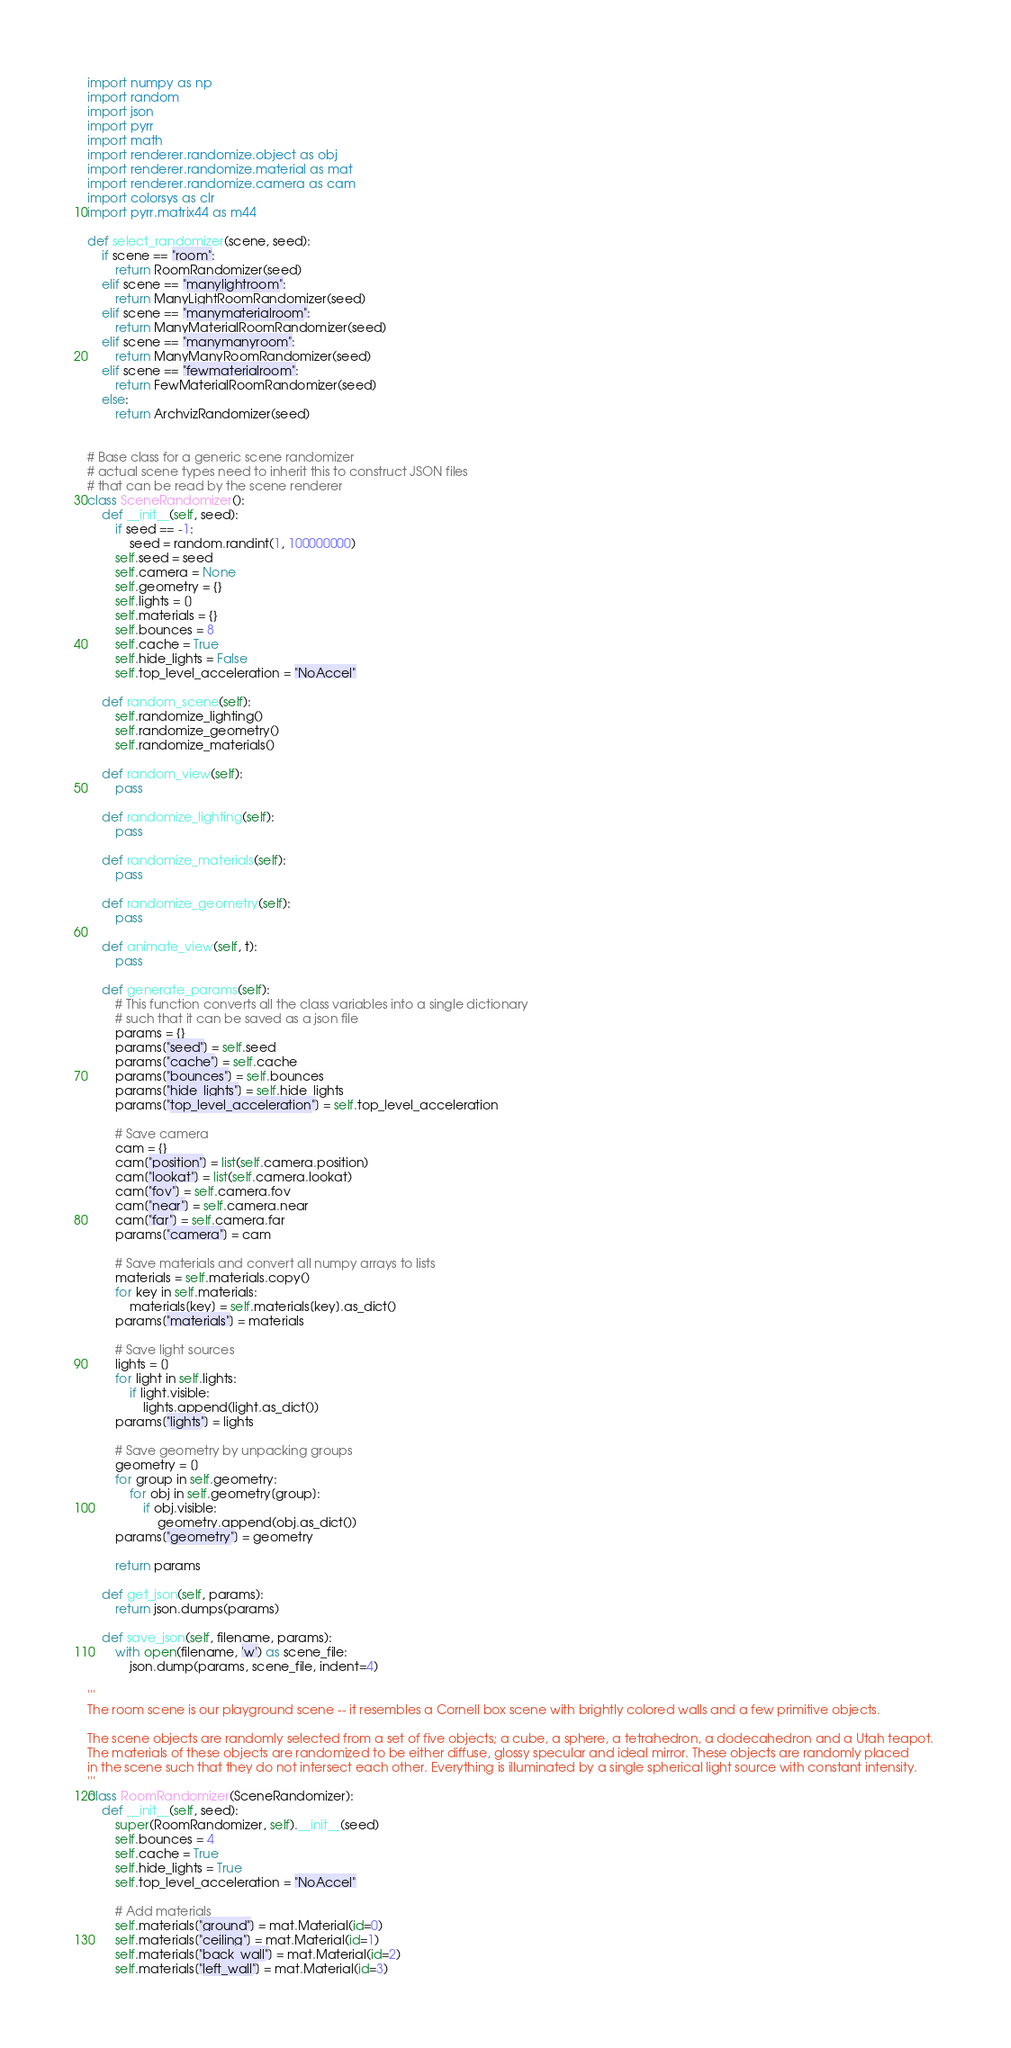<code> <loc_0><loc_0><loc_500><loc_500><_Python_>import numpy as np
import random
import json
import pyrr
import math
import renderer.randomize.object as obj
import renderer.randomize.material as mat
import renderer.randomize.camera as cam
import colorsys as clr
import pyrr.matrix44 as m44

def select_randomizer(scene, seed):
    if scene == "room":
        return RoomRandomizer(seed)
    elif scene == "manylightroom":
        return ManyLightRoomRandomizer(seed)
    elif scene == "manymaterialroom":
        return ManyMaterialRoomRandomizer(seed)
    elif scene == "manymanyroom":
        return ManyManyRoomRandomizer(seed)
    elif scene == "fewmaterialroom":
        return FewMaterialRoomRandomizer(seed)
    else:
        return ArchvizRandomizer(seed)


# Base class for a generic scene randomizer
# actual scene types need to inherit this to construct JSON files
# that can be read by the scene renderer
class SceneRandomizer():
    def __init__(self, seed):
        if seed == -1:
            seed = random.randint(1, 100000000)
        self.seed = seed
        self.camera = None
        self.geometry = {}
        self.lights = []
        self.materials = {}
        self.bounces = 8
        self.cache = True
        self.hide_lights = False
        self.top_level_acceleration = "NoAccel"

    def random_scene(self):
        self.randomize_lighting()
        self.randomize_geometry()
        self.randomize_materials()

    def random_view(self):
        pass

    def randomize_lighting(self):
        pass

    def randomize_materials(self):
        pass

    def randomize_geometry(self):
        pass

    def animate_view(self, t):
        pass
    
    def generate_params(self):
        # This function converts all the class variables into a single dictionary
        # such that it can be saved as a json file
        params = {}
        params["seed"] = self.seed
        params["cache"] = self.cache
        params["bounces"] = self.bounces
        params["hide_lights"] = self.hide_lights
        params["top_level_acceleration"] = self.top_level_acceleration

        # Save camera
        cam = {}
        cam["position"] = list(self.camera.position)
        cam["lookat"] = list(self.camera.lookat)
        cam["fov"] = self.camera.fov
        cam["near"] = self.camera.near
        cam["far"] = self.camera.far
        params["camera"] = cam
        
        # Save materials and convert all numpy arrays to lists
        materials = self.materials.copy()
        for key in self.materials:
            materials[key] = self.materials[key].as_dict()
        params["materials"] = materials

        # Save light sources
        lights = []
        for light in self.lights:
            if light.visible:
                lights.append(light.as_dict())
        params["lights"] = lights

        # Save geometry by unpacking groups
        geometry = []
        for group in self.geometry:
            for obj in self.geometry[group]:
                if obj.visible:
                    geometry.append(obj.as_dict())
        params["geometry"] = geometry
             
        return params

    def get_json(self, params):
        return json.dumps(params)

    def save_json(self, filename, params):
        with open(filename, 'w') as scene_file:
            json.dump(params, scene_file, indent=4)

'''
The room scene is our playground scene -- it resembles a Cornell box scene with brightly colored walls and a few primitive objects.

The scene objects are randomly selected from a set of five objects; a cube, a sphere, a tetrahedron, a dodecahedron and a Utah teapot. 
The materials of these objects are randomized to be either diffuse, glossy specular and ideal mirror. These objects are randomly placed
in the scene such that they do not intersect each other. Everything is illuminated by a single spherical light source with constant intensity. 
'''
class RoomRandomizer(SceneRandomizer):
    def __init__(self, seed):
        super(RoomRandomizer, self).__init__(seed)
        self.bounces = 4
        self.cache = True
        self.hide_lights = True
        self.top_level_acceleration = "NoAccel"

        # Add materials
        self.materials["ground"] = mat.Material(id=0)
        self.materials["ceiling"] = mat.Material(id=1)
        self.materials["back_wall"] = mat.Material(id=2)
        self.materials["left_wall"] = mat.Material(id=3)</code> 